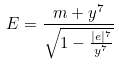<formula> <loc_0><loc_0><loc_500><loc_500>E = \frac { m + y ^ { 7 } } { \sqrt { 1 - \frac { | e | ^ { 7 } } { y ^ { 7 } } } }</formula> 